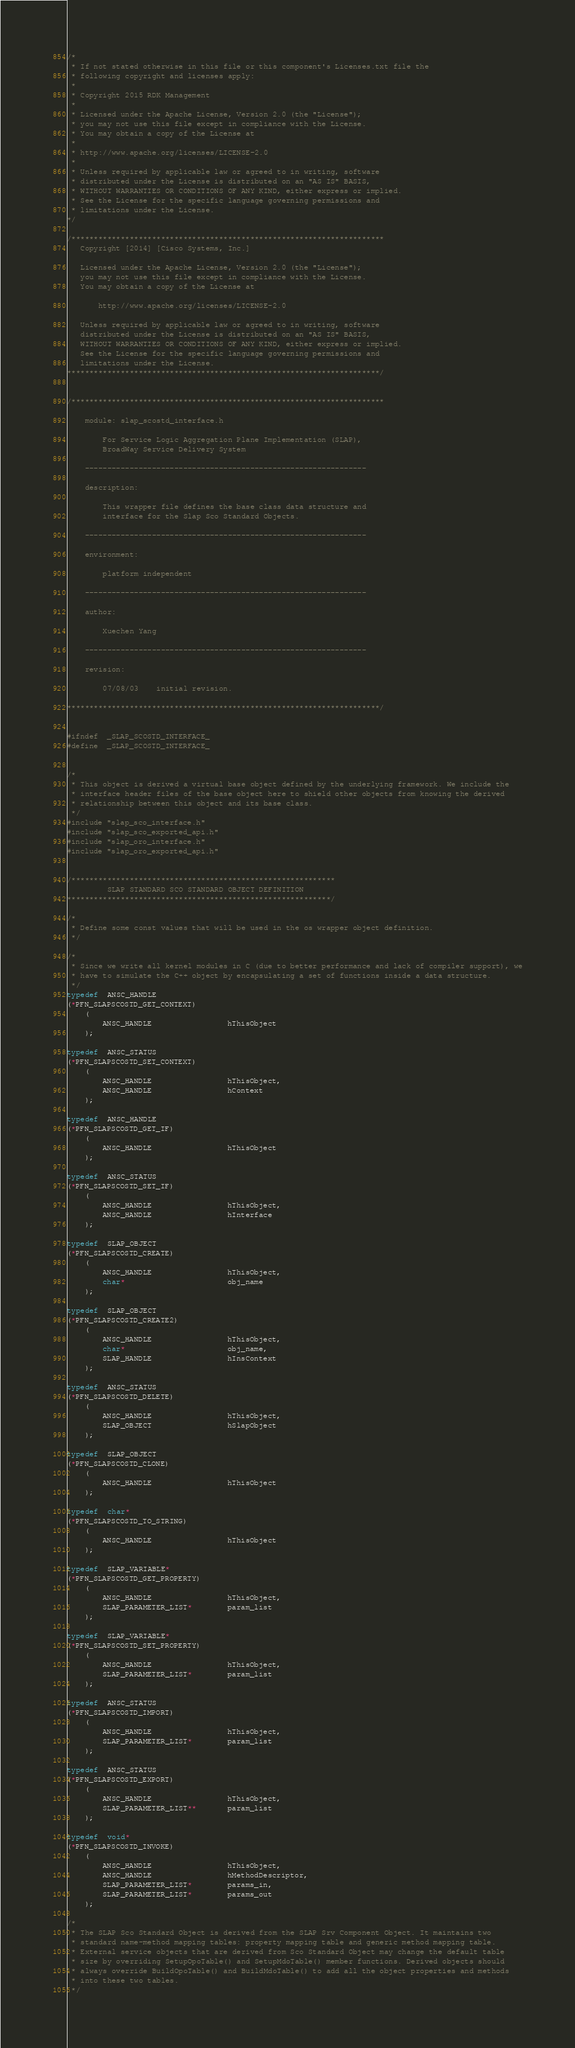Convert code to text. <code><loc_0><loc_0><loc_500><loc_500><_C_>/*
 * If not stated otherwise in this file or this component's Licenses.txt file the
 * following copyright and licenses apply:
 *
 * Copyright 2015 RDK Management
 *
 * Licensed under the Apache License, Version 2.0 (the "License");
 * you may not use this file except in compliance with the License.
 * You may obtain a copy of the License at
 *
 * http://www.apache.org/licenses/LICENSE-2.0
 *
 * Unless required by applicable law or agreed to in writing, software
 * distributed under the License is distributed on an "AS IS" BASIS,
 * WITHOUT WARRANTIES OR CONDITIONS OF ANY KIND, either express or implied.
 * See the License for the specific language governing permissions and
 * limitations under the License.
*/

/**********************************************************************
   Copyright [2014] [Cisco Systems, Inc.]
 
   Licensed under the Apache License, Version 2.0 (the "License");
   you may not use this file except in compliance with the License.
   You may obtain a copy of the License at
 
       http://www.apache.org/licenses/LICENSE-2.0
 
   Unless required by applicable law or agreed to in writing, software
   distributed under the License is distributed on an "AS IS" BASIS,
   WITHOUT WARRANTIES OR CONDITIONS OF ANY KIND, either express or implied.
   See the License for the specific language governing permissions and
   limitations under the License.
**********************************************************************/


/**********************************************************************

    module:	slap_scostd_interface.h

        For Service Logic Aggregation Plane Implementation (SLAP),
        BroadWay Service Delivery System

    ---------------------------------------------------------------

    description:

        This wrapper file defines the base class data structure and
        interface for the Slap Sco Standard Objects.

    ---------------------------------------------------------------

    environment:

        platform independent

    ---------------------------------------------------------------

    author:

        Xuechen Yang

    ---------------------------------------------------------------

    revision:

        07/08/03    initial revision.

**********************************************************************/


#ifndef  _SLAP_SCOSTD_INTERFACE_
#define  _SLAP_SCOSTD_INTERFACE_


/*
 * This object is derived a virtual base object defined by the underlying framework. We include the
 * interface header files of the base object here to shield other objects from knowing the derived
 * relationship between this object and its base class.
 */
#include "slap_sco_interface.h"
#include "slap_sco_exported_api.h"
#include "slap_oro_interface.h"
#include "slap_oro_exported_api.h"


/***********************************************************
         SLAP STANDARD SCO STANDARD OBJECT DEFINITION
***********************************************************/

/*
 * Define some const values that will be used in the os wrapper object definition.
 */

/*
 * Since we write all kernel modules in C (due to better performance and lack of compiler support), we
 * have to simulate the C++ object by encapsulating a set of functions inside a data structure.
 */
typedef  ANSC_HANDLE
(*PFN_SLAPSCOSTD_GET_CONTEXT)
    (
        ANSC_HANDLE                 hThisObject
    );

typedef  ANSC_STATUS
(*PFN_SLAPSCOSTD_SET_CONTEXT)
    (
        ANSC_HANDLE                 hThisObject,
        ANSC_HANDLE                 hContext
    );

typedef  ANSC_HANDLE
(*PFN_SLAPSCOSTD_GET_IF)
    (
        ANSC_HANDLE                 hThisObject
    );

typedef  ANSC_STATUS
(*PFN_SLAPSCOSTD_SET_IF)
    (
        ANSC_HANDLE                 hThisObject,
        ANSC_HANDLE                 hInterface
    );

typedef  SLAP_OBJECT
(*PFN_SLAPSCOSTD_CREATE)
    (
        ANSC_HANDLE                 hThisObject,
        char*                       obj_name
    );

typedef  SLAP_OBJECT
(*PFN_SLAPSCOSTD_CREATE2)
    (
        ANSC_HANDLE                 hThisObject,
        char*                       obj_name,
        SLAP_HANDLE                 hInsContext
    );

typedef  ANSC_STATUS
(*PFN_SLAPSCOSTD_DELETE)
    (
        ANSC_HANDLE                 hThisObject,
        SLAP_OBJECT                 hSlapObject
    );

typedef  SLAP_OBJECT
(*PFN_SLAPSCOSTD_CLONE)
    (
        ANSC_HANDLE                 hThisObject
    );

typedef  char*
(*PFN_SLAPSCOSTD_TO_STRING)
    (
        ANSC_HANDLE                 hThisObject
    );

typedef  SLAP_VARIABLE*
(*PFN_SLAPSCOSTD_GET_PROPERTY)
    (
        ANSC_HANDLE                 hThisObject,
        SLAP_PARAMETER_LIST*        param_list
    );

typedef  SLAP_VARIABLE*
(*PFN_SLAPSCOSTD_SET_PROPERTY)
    (
        ANSC_HANDLE                 hThisObject,
        SLAP_PARAMETER_LIST*        param_list
    );

typedef  ANSC_STATUS
(*PFN_SLAPSCOSTD_IMPORT)
    (
        ANSC_HANDLE                 hThisObject,
        SLAP_PARAMETER_LIST*        param_list
    );

typedef  ANSC_STATUS
(*PFN_SLAPSCOSTD_EXPORT)
    (
        ANSC_HANDLE                 hThisObject,
        SLAP_PARAMETER_LIST**       param_list
    );

typedef  void*
(*PFN_SLAPSCOSTD_INVOKE)
    (
        ANSC_HANDLE                 hThisObject,
        ANSC_HANDLE                 hMethodDescriptor,
        SLAP_PARAMETER_LIST*        params_in,
        SLAP_PARAMETER_LIST*        params_out
    );

/*
 * The SLAP Sco Standard Object is derived from the SLAP Srv Component Object. It maintains two
 * standard name-method mapping tables: property mapping table and generic method mapping table.
 * External service objects that are derived from Sco Standard Object may change the default table
 * size by overriding SetupOpoTable() and SetupMdoTable() member functions. Derived objects should
 * always override BuildOpoTable() and BuildMdoTable() to add all the object properties and methods
 * into these two tables.
 */</code> 